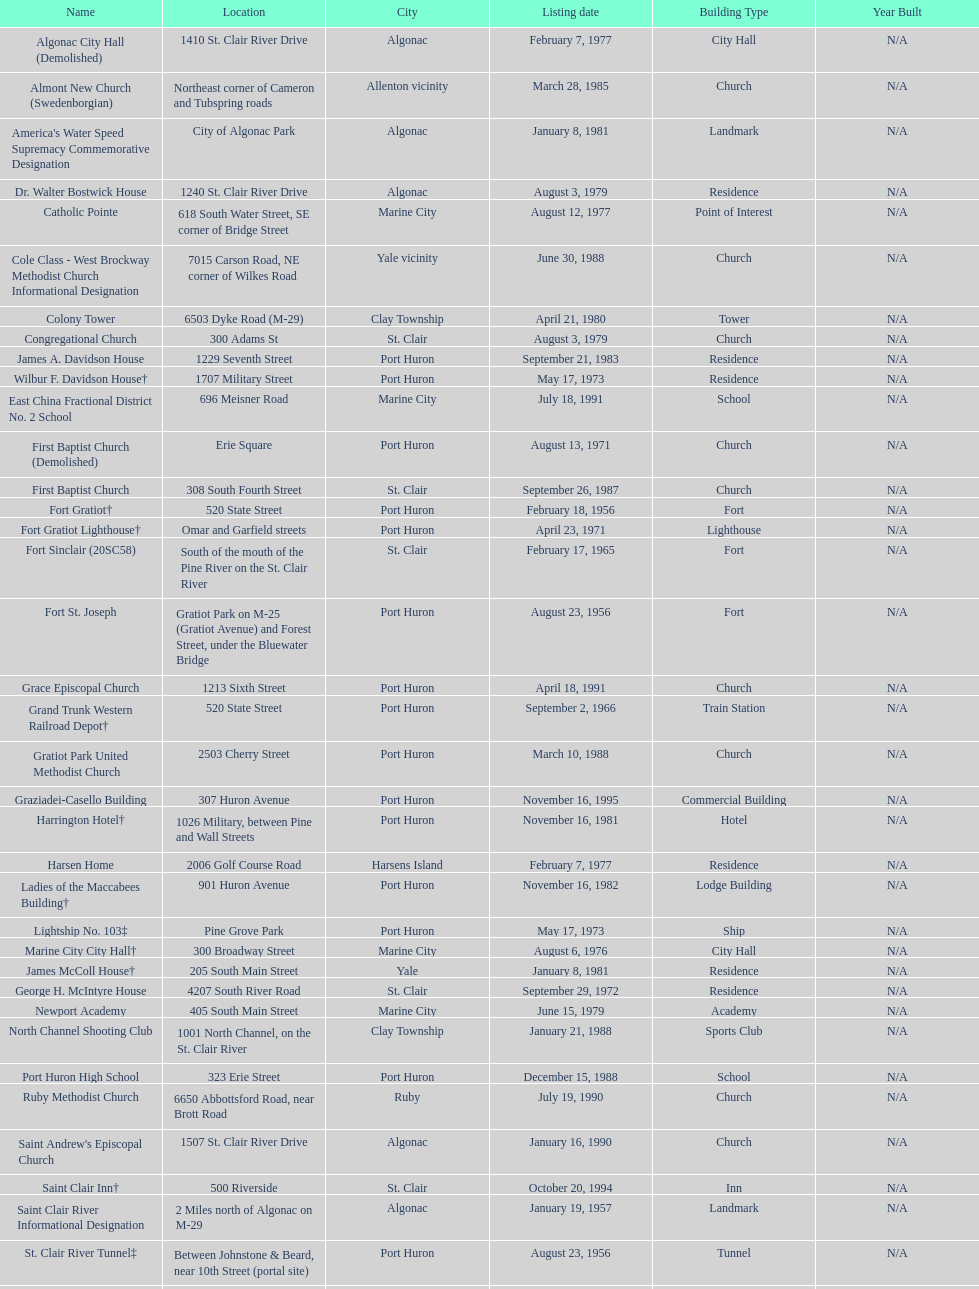What is the total number of locations in the city of algonac? 5. 